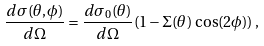<formula> <loc_0><loc_0><loc_500><loc_500>\frac { d \sigma ( \theta , \phi ) } { d \Omega } = \frac { d \sigma _ { 0 } ( \theta ) } { d \Omega } ( 1 - \Sigma ( \theta ) \, \cos ( 2 \phi ) ) \, ,</formula> 